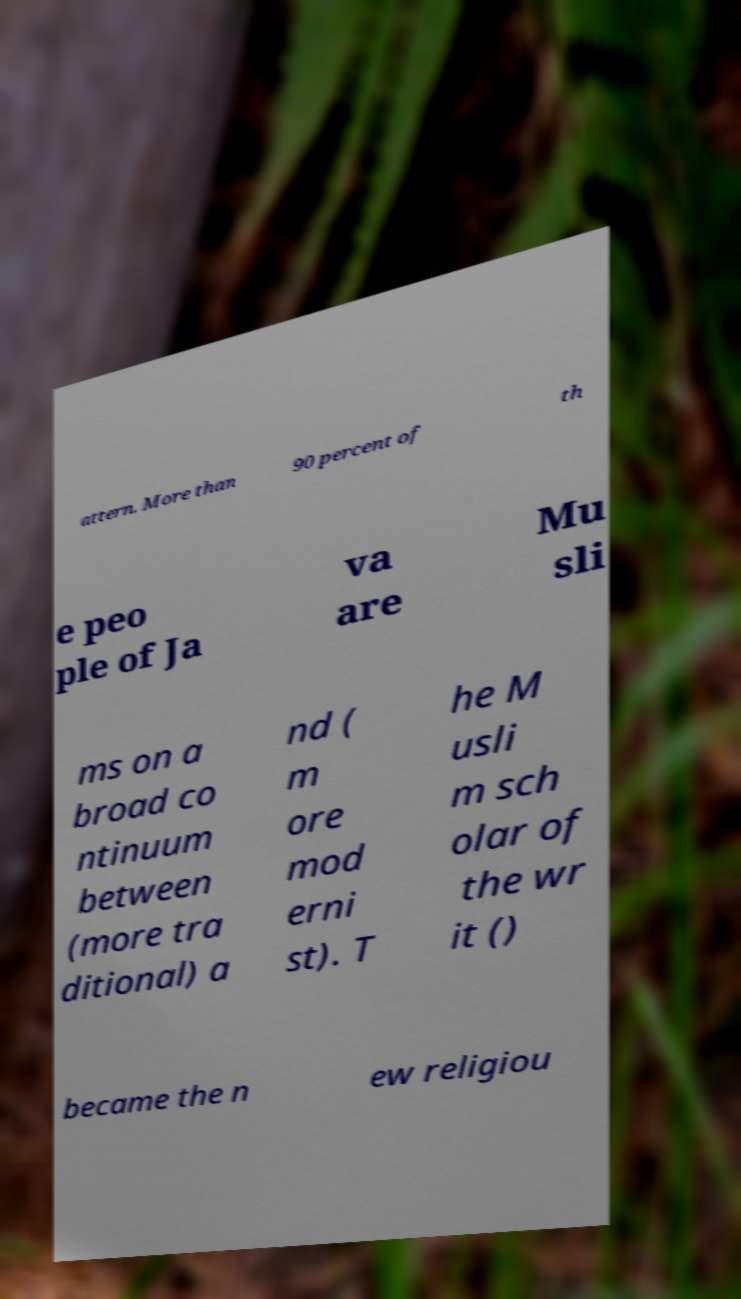Please read and relay the text visible in this image. What does it say? attern. More than 90 percent of th e peo ple of Ja va are Mu sli ms on a broad co ntinuum between (more tra ditional) a nd ( m ore mod erni st). T he M usli m sch olar of the wr it () became the n ew religiou 